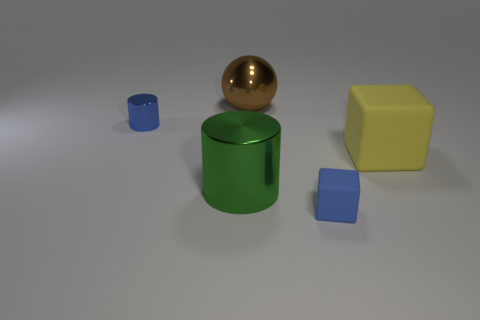Add 3 big objects. How many objects exist? 8 Subtract all balls. How many objects are left? 4 Subtract 1 brown balls. How many objects are left? 4 Subtract all tiny yellow metal balls. Subtract all tiny blue rubber blocks. How many objects are left? 4 Add 4 big green objects. How many big green objects are left? 5 Add 2 large brown rubber cylinders. How many large brown rubber cylinders exist? 2 